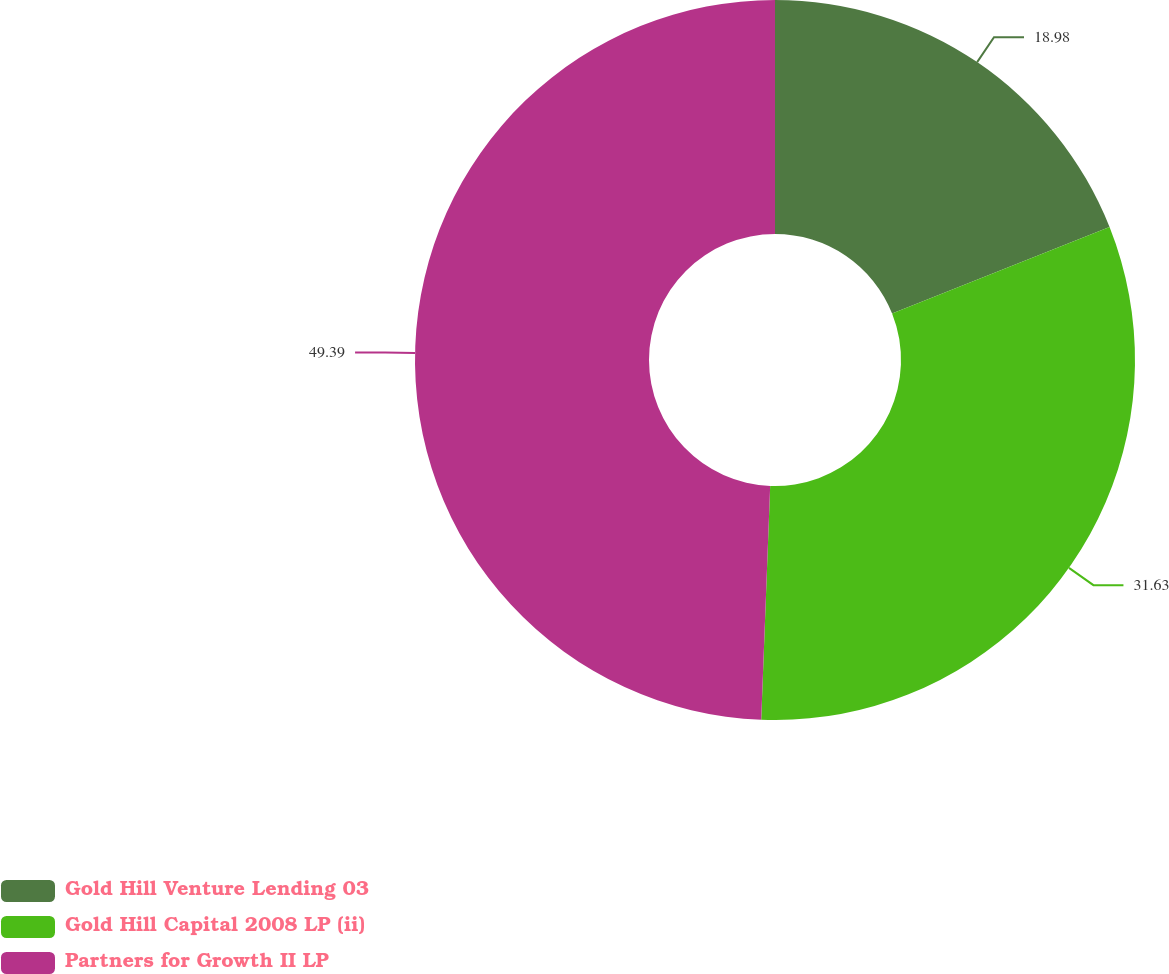Convert chart. <chart><loc_0><loc_0><loc_500><loc_500><pie_chart><fcel>Gold Hill Venture Lending 03<fcel>Gold Hill Capital 2008 LP (ii)<fcel>Partners for Growth II LP<nl><fcel>18.98%<fcel>31.63%<fcel>49.39%<nl></chart> 